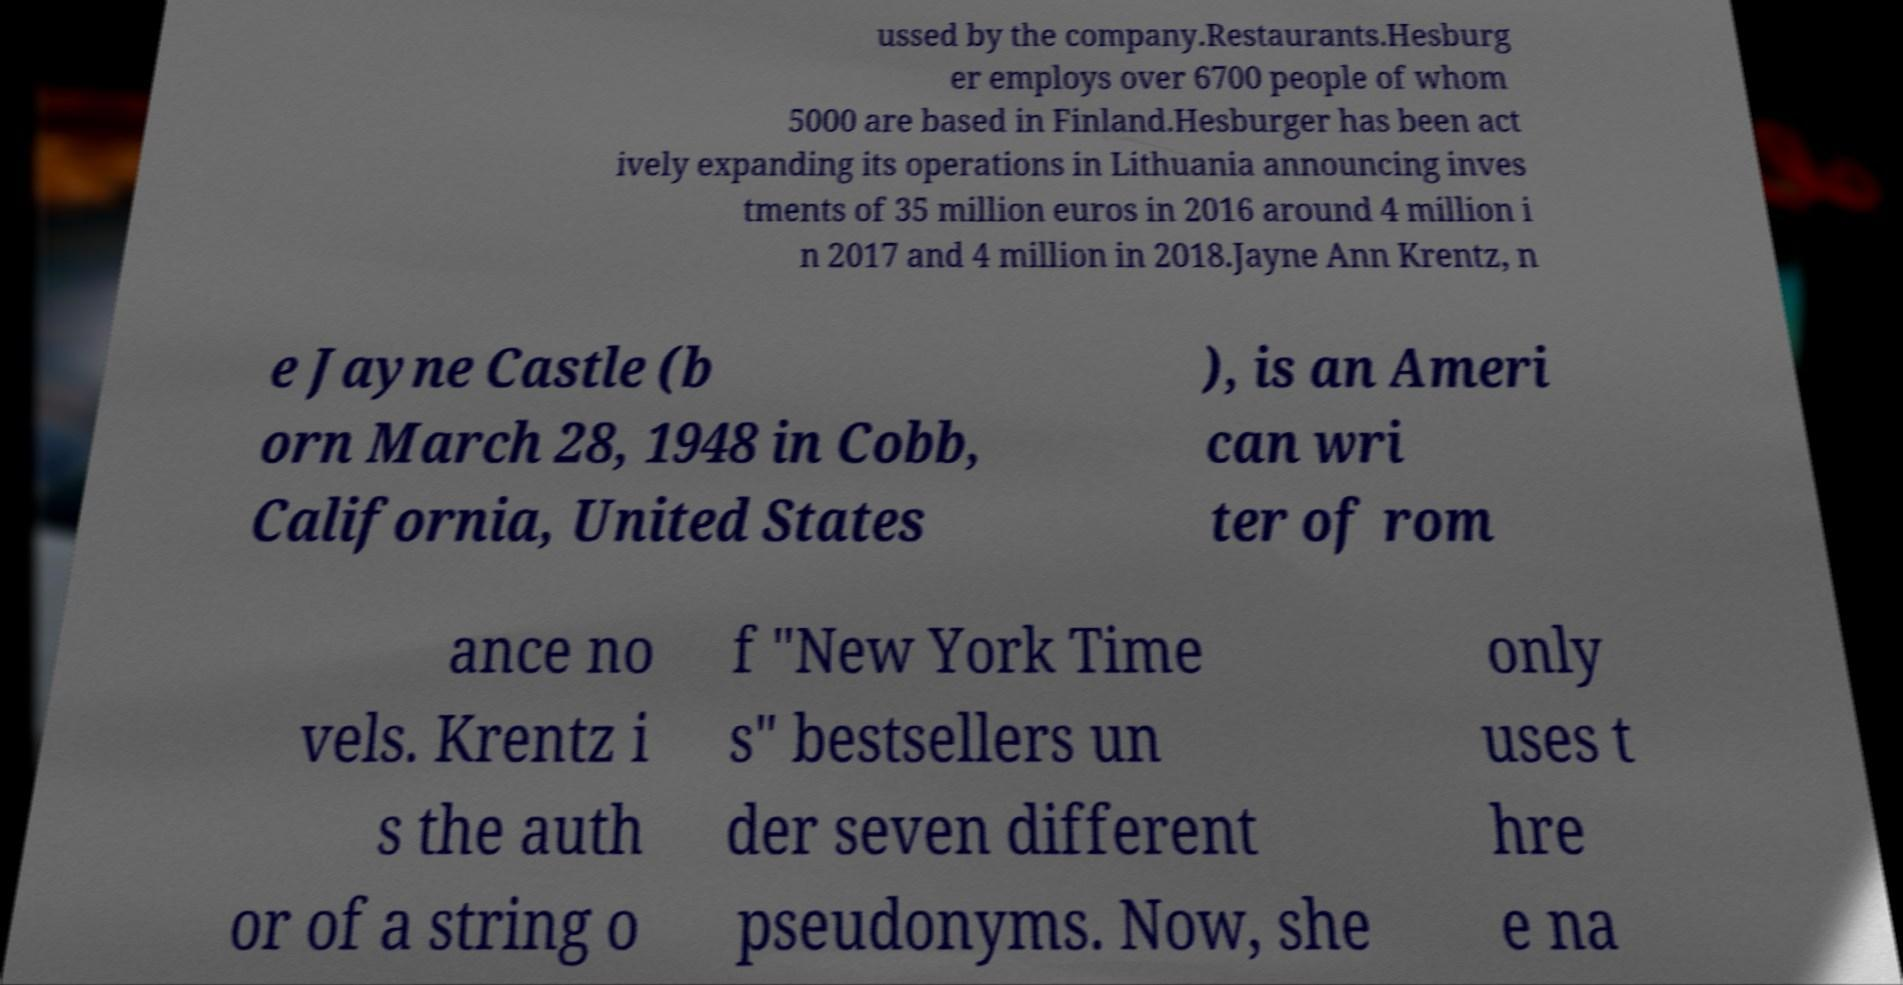Please identify and transcribe the text found in this image. ussed by the company.Restaurants.Hesburg er employs over 6700 people of whom 5000 are based in Finland.Hesburger has been act ively expanding its operations in Lithuania announcing inves tments of 35 million euros in 2016 around 4 million i n 2017 and 4 million in 2018.Jayne Ann Krentz, n e Jayne Castle (b orn March 28, 1948 in Cobb, California, United States ), is an Ameri can wri ter of rom ance no vels. Krentz i s the auth or of a string o f "New York Time s" bestsellers un der seven different pseudonyms. Now, she only uses t hre e na 